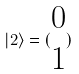Convert formula to latex. <formula><loc_0><loc_0><loc_500><loc_500>| 2 \rangle = ( \begin{matrix} 0 \\ 1 \end{matrix} )</formula> 